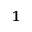Convert formula to latex. <formula><loc_0><loc_0><loc_500><loc_500>^ { 1 }</formula> 